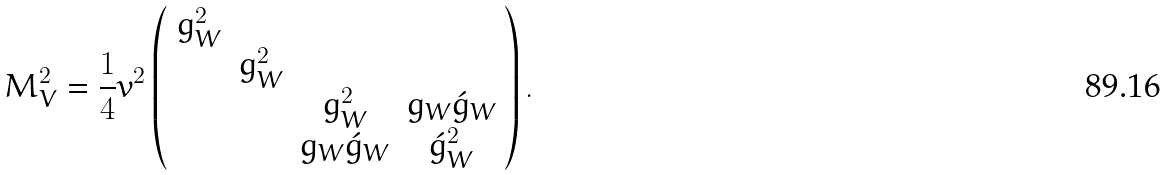Convert formula to latex. <formula><loc_0><loc_0><loc_500><loc_500>M _ { V } ^ { 2 } = \frac { 1 } { 4 } v ^ { 2 } \left ( \begin{array} { c c c c } g _ { W } ^ { 2 } & & & \\ & g _ { W } ^ { 2 } & & \\ & & g _ { W } ^ { 2 } & g _ { W } \acute { g } _ { W } \\ & & g _ { W } \acute { g } _ { W } & \acute { g } _ { W } ^ { 2 } \end{array} \right ) .</formula> 